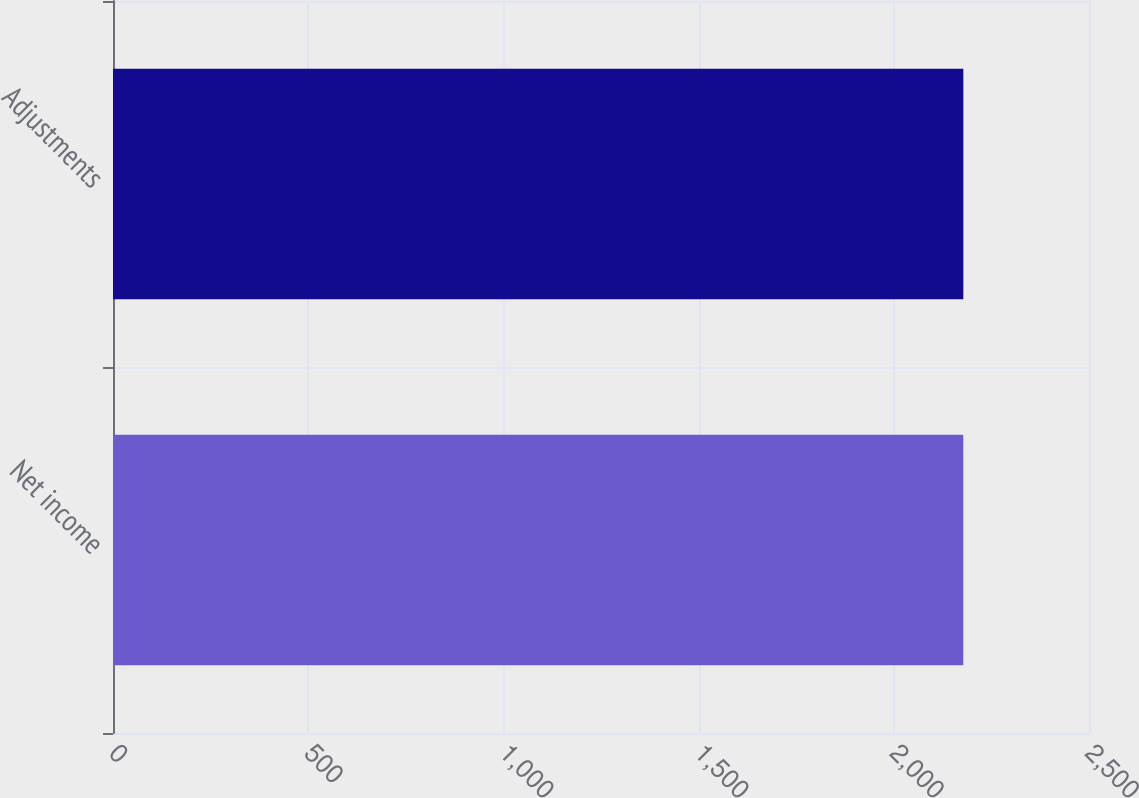Convert chart. <chart><loc_0><loc_0><loc_500><loc_500><bar_chart><fcel>Net income<fcel>Adjustments<nl><fcel>2178<fcel>2178.1<nl></chart> 